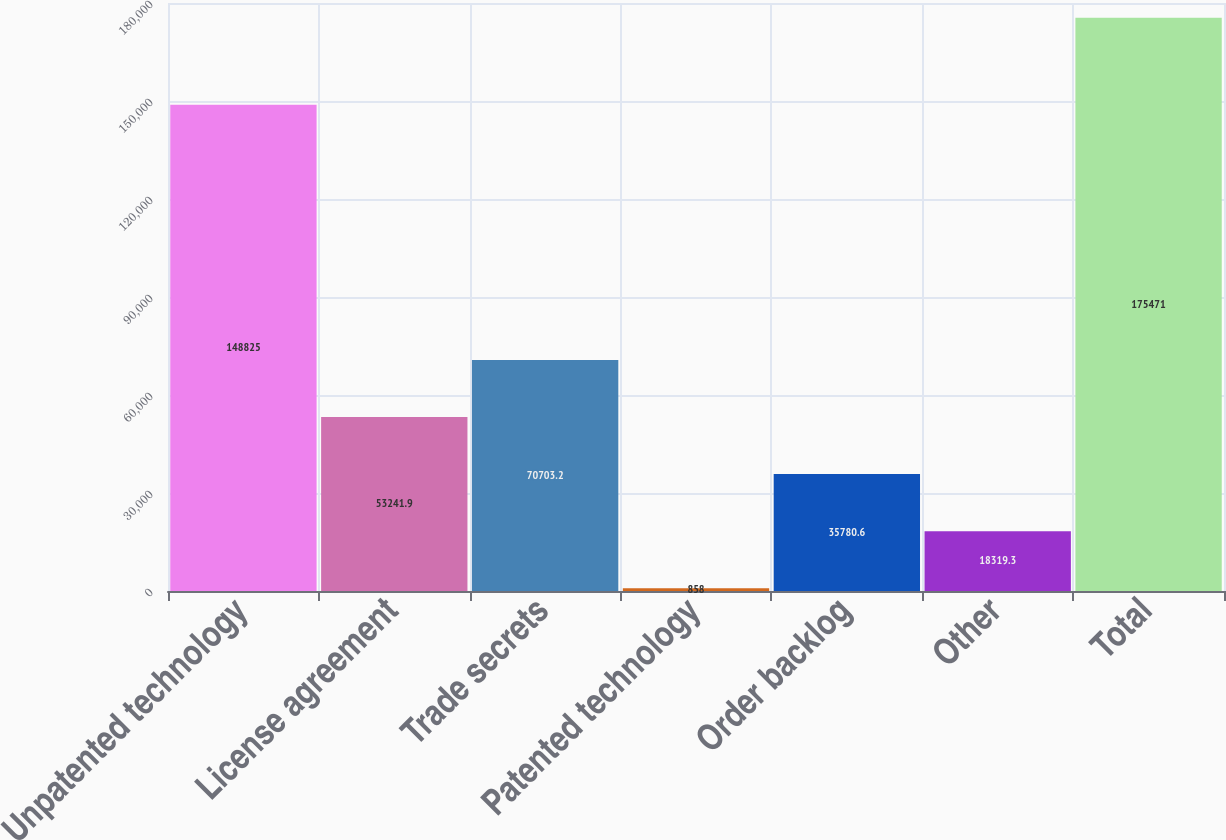Convert chart to OTSL. <chart><loc_0><loc_0><loc_500><loc_500><bar_chart><fcel>Unpatented technology<fcel>License agreement<fcel>Trade secrets<fcel>Patented technology<fcel>Order backlog<fcel>Other<fcel>Total<nl><fcel>148825<fcel>53241.9<fcel>70703.2<fcel>858<fcel>35780.6<fcel>18319.3<fcel>175471<nl></chart> 